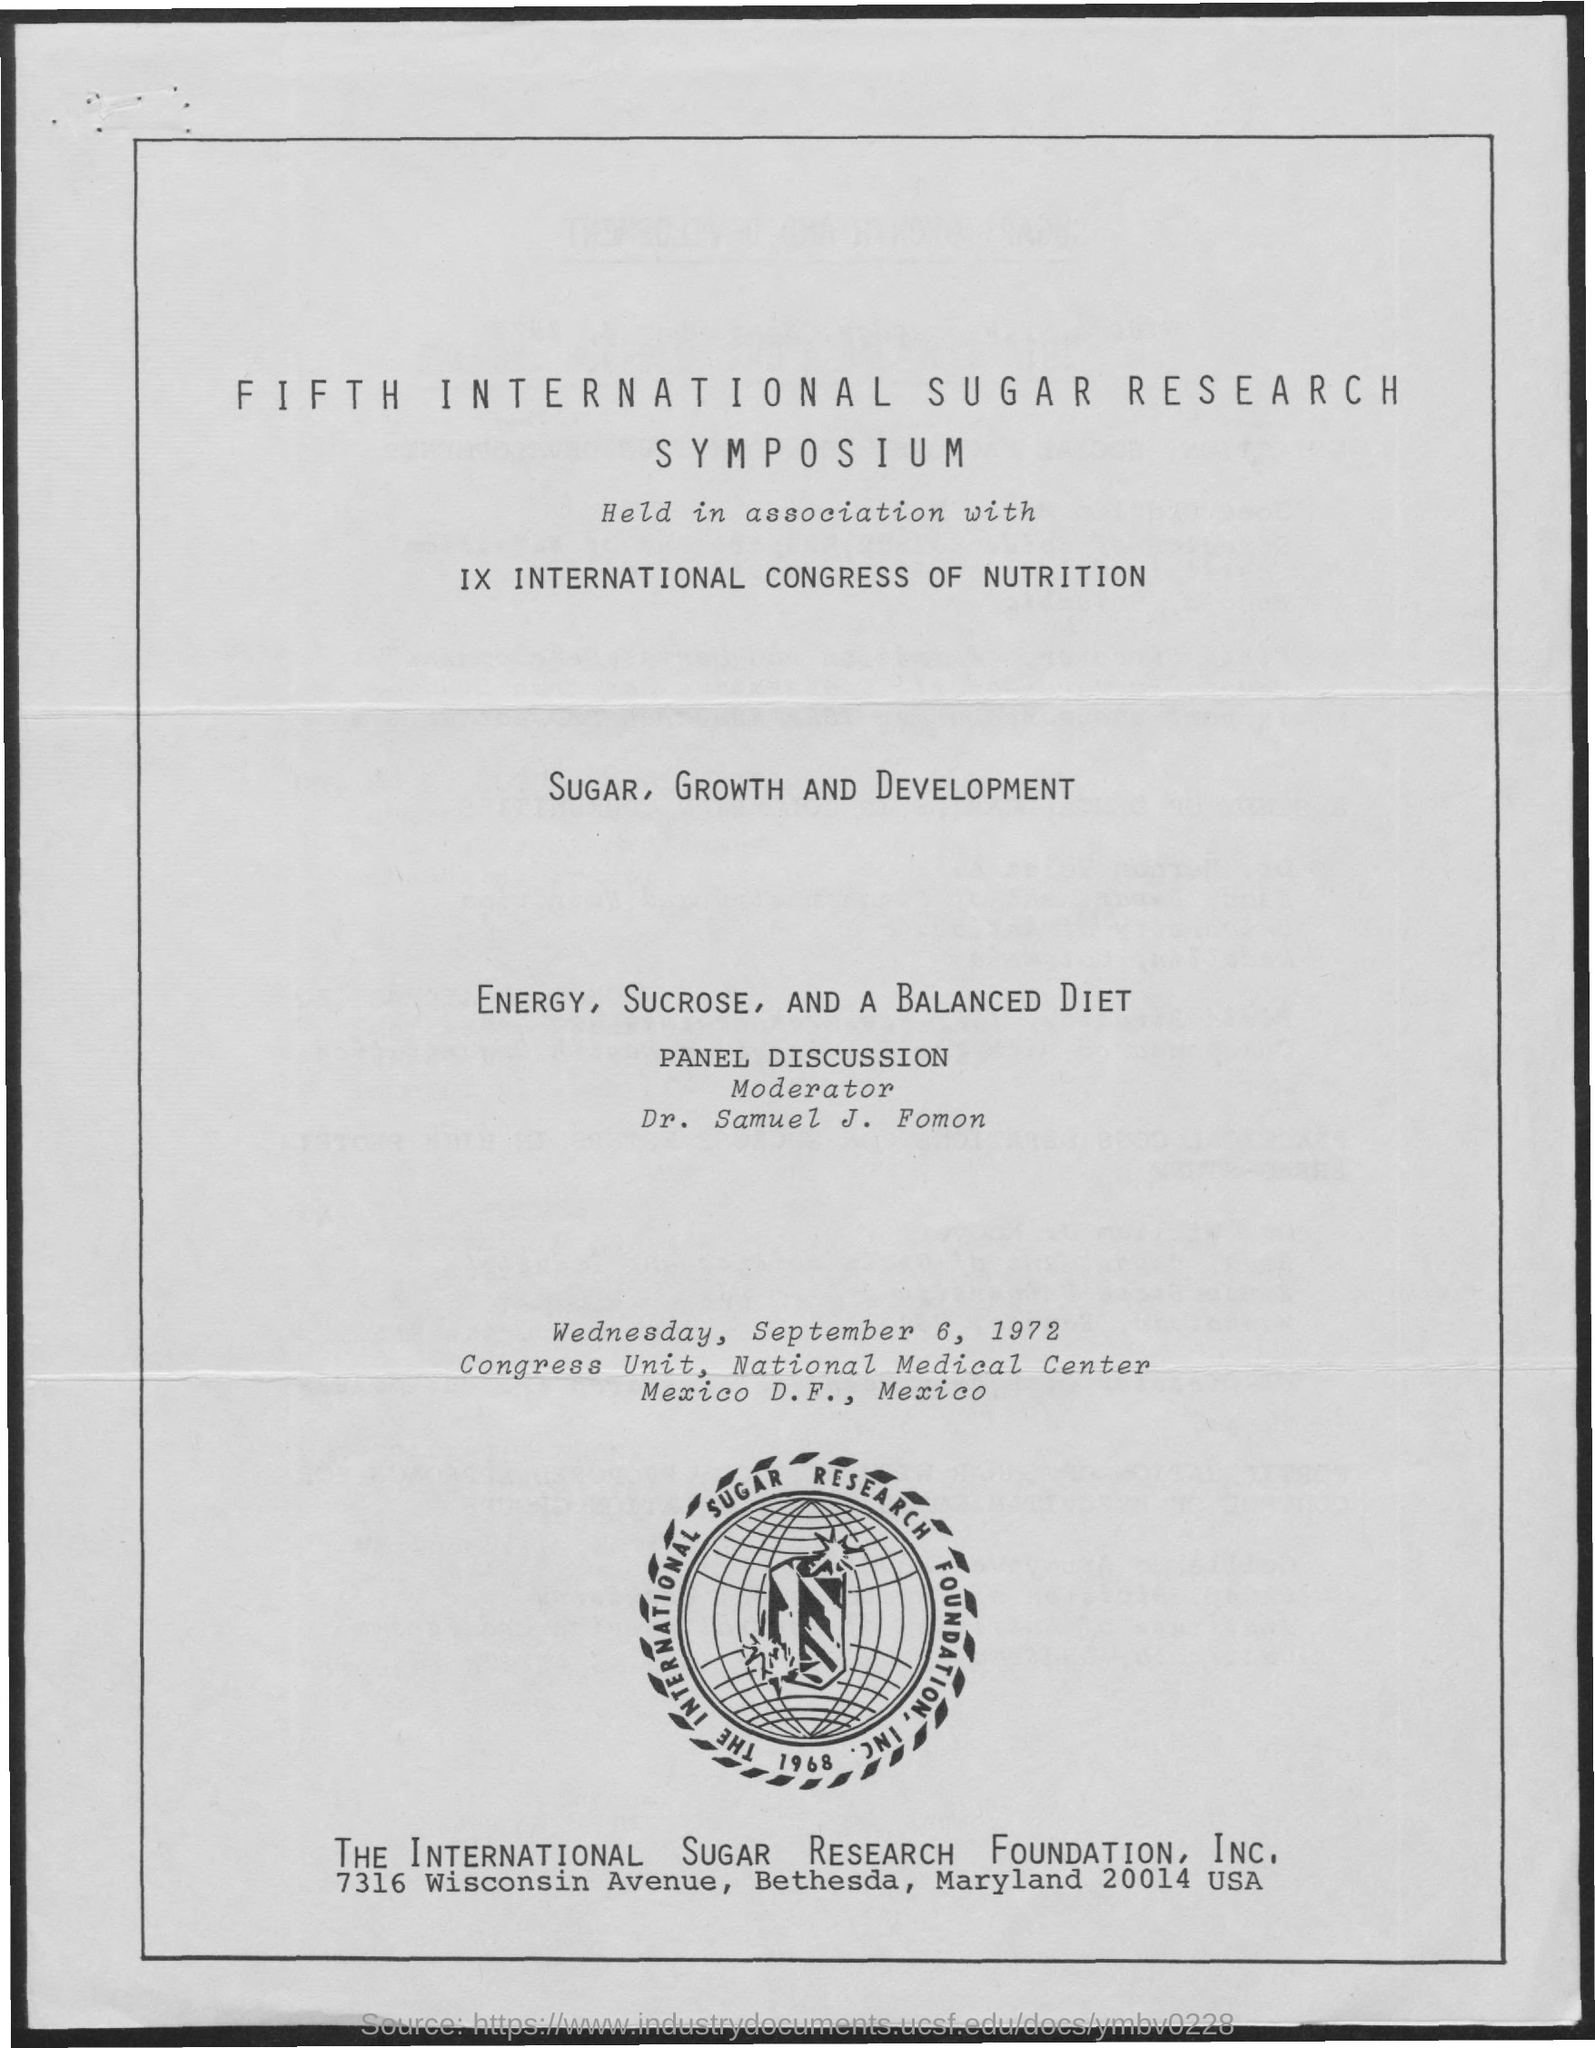Mention a couple of crucial points in this snapshot. In 1968, the International Sugar Research Foundation was established. 